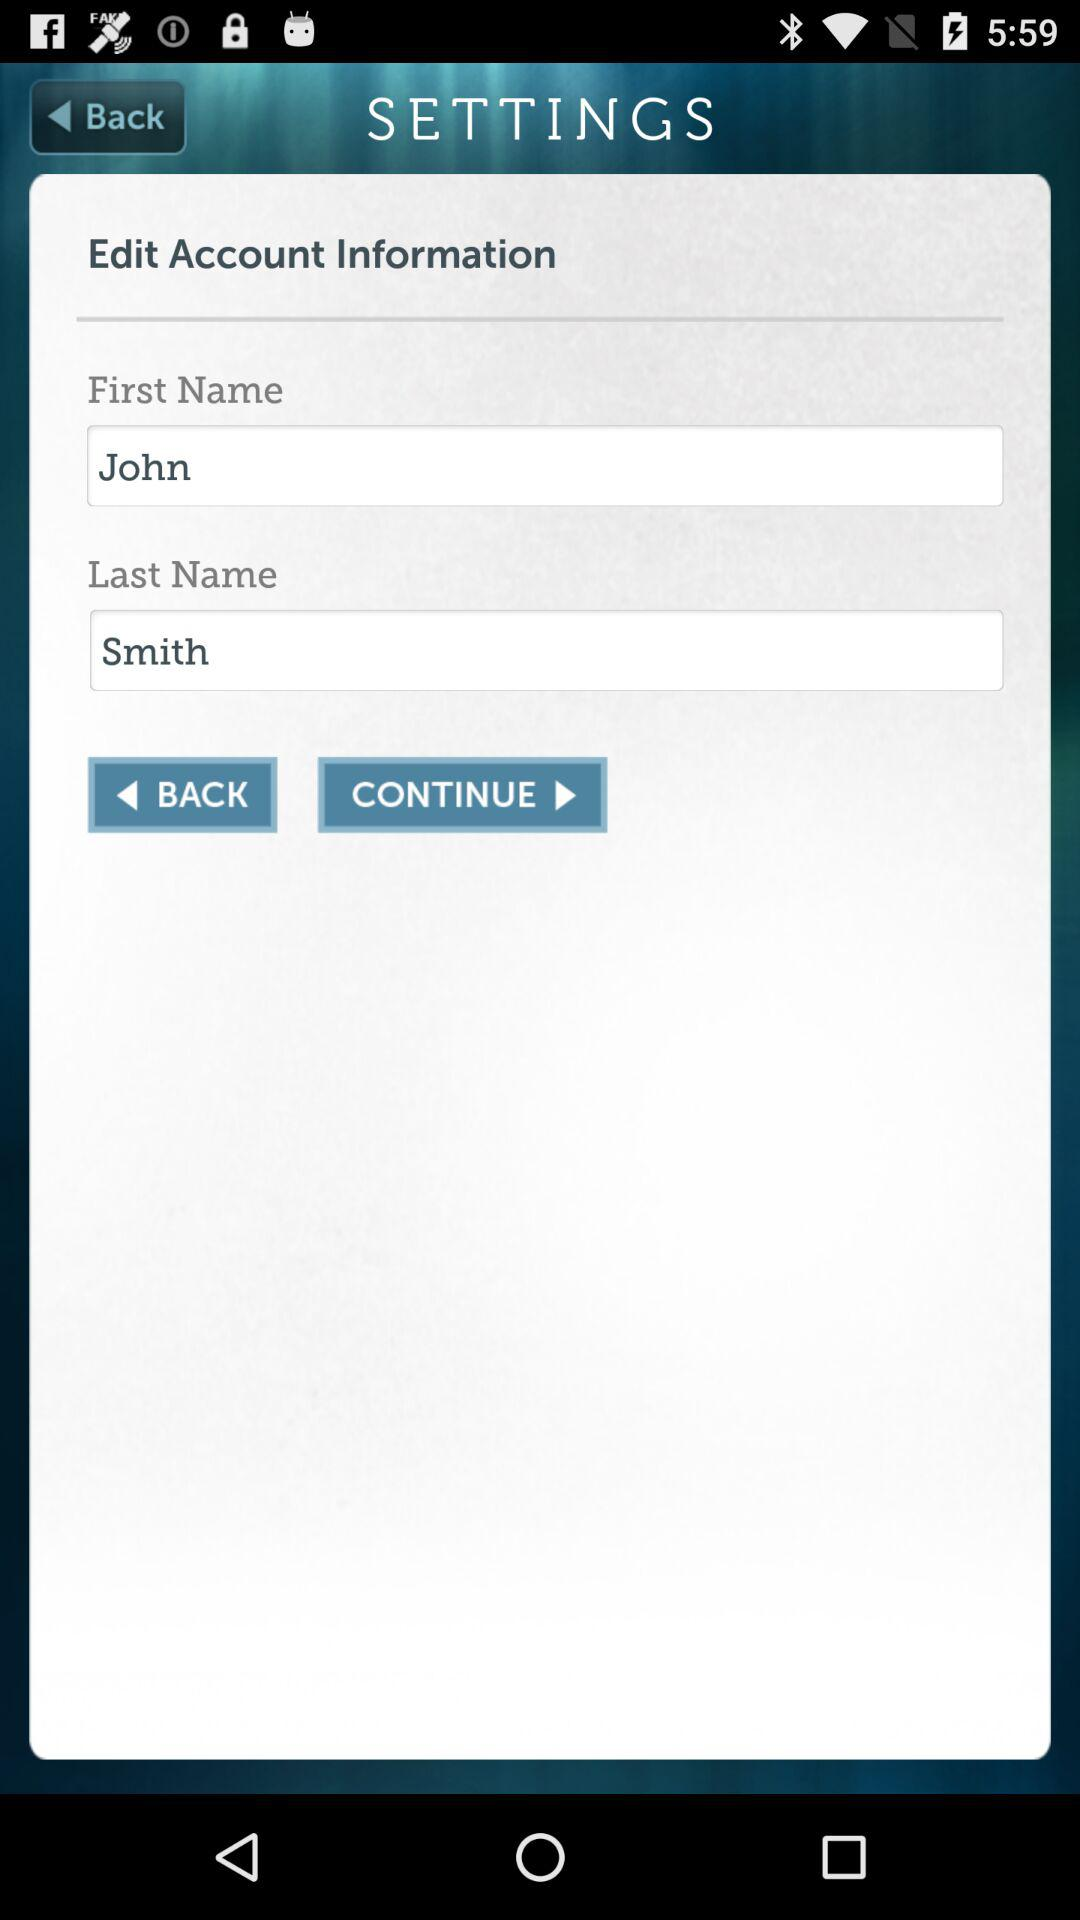What is the last name in the edit account information? The last name is Smith. 